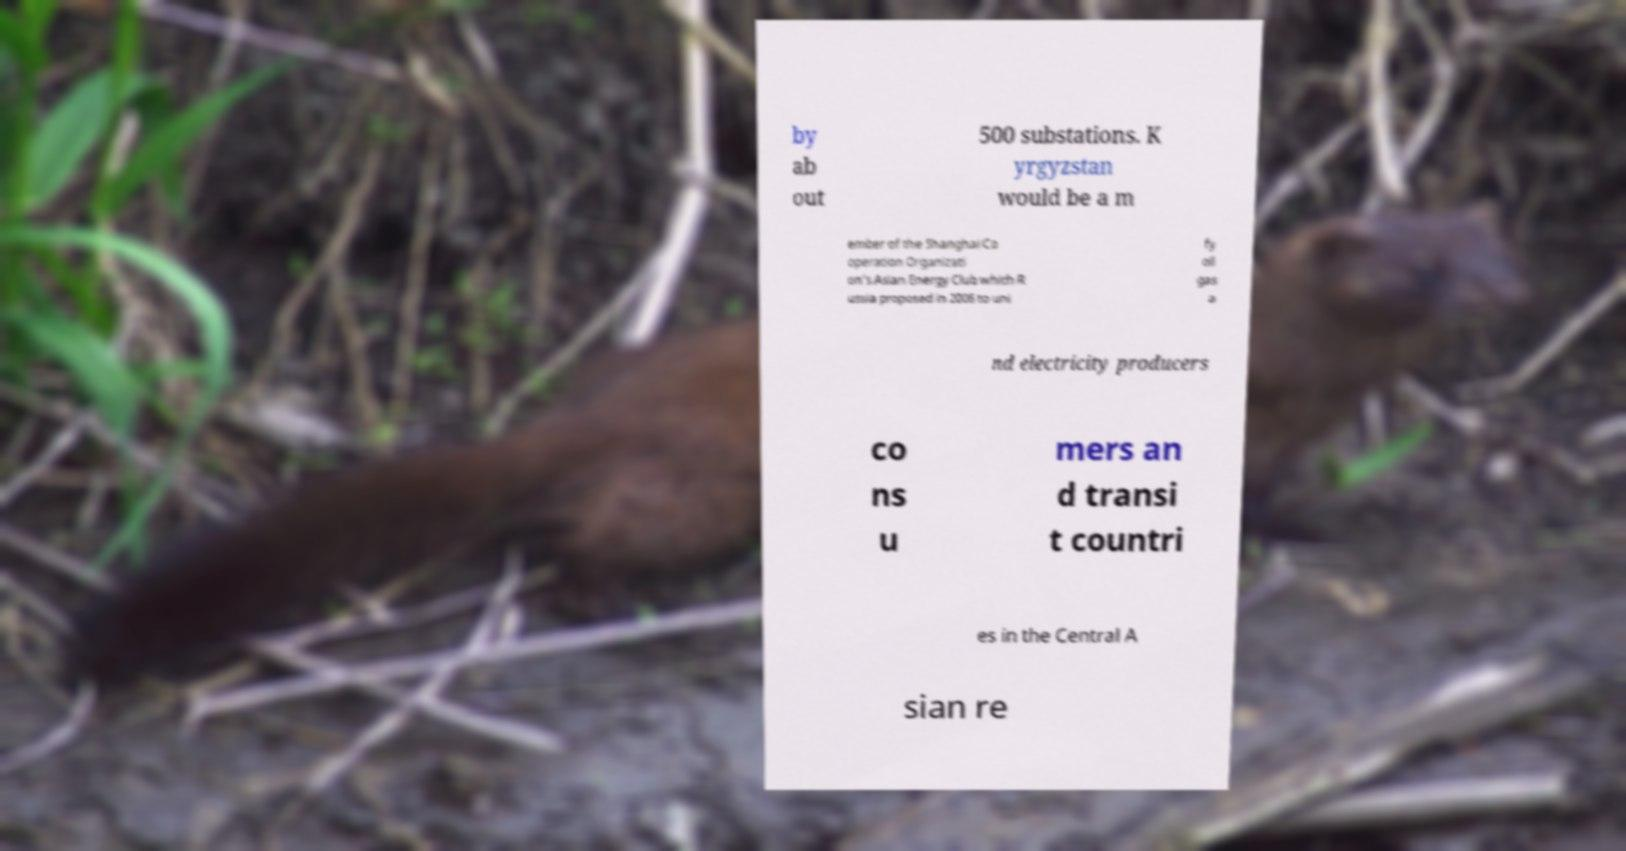Could you assist in decoding the text presented in this image and type it out clearly? by ab out 500 substations. K yrgyzstan would be a m ember of the Shanghai Co operation Organizati on’s Asian Energy Club which R ussia proposed in 2006 to uni fy oil gas a nd electricity producers co ns u mers an d transi t countri es in the Central A sian re 